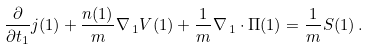<formula> <loc_0><loc_0><loc_500><loc_500>\frac { \partial } { \partial t _ { 1 } } { j } ( 1 ) + \frac { n ( 1 ) } { m } { \nabla } _ { \, 1 } V ( 1 ) + \frac { 1 } { m } { \nabla } _ { \, 1 } \cdot { \Pi } ( 1 ) = \frac { 1 } { m } { S } ( 1 ) \, .</formula> 